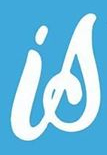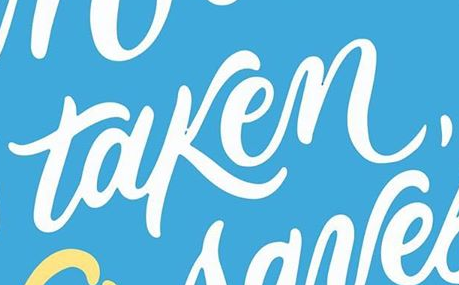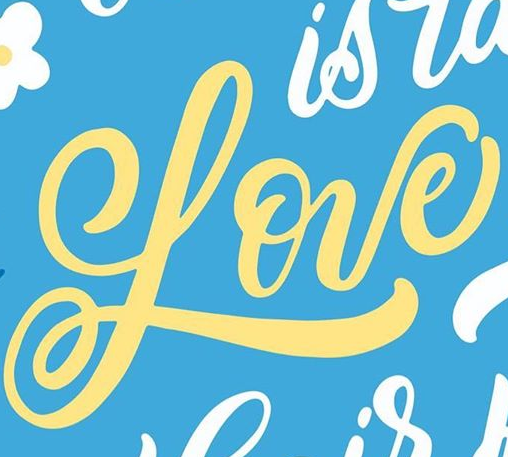Identify the words shown in these images in order, separated by a semicolon. is; taken,; Love 